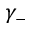<formula> <loc_0><loc_0><loc_500><loc_500>\gamma _ { - }</formula> 